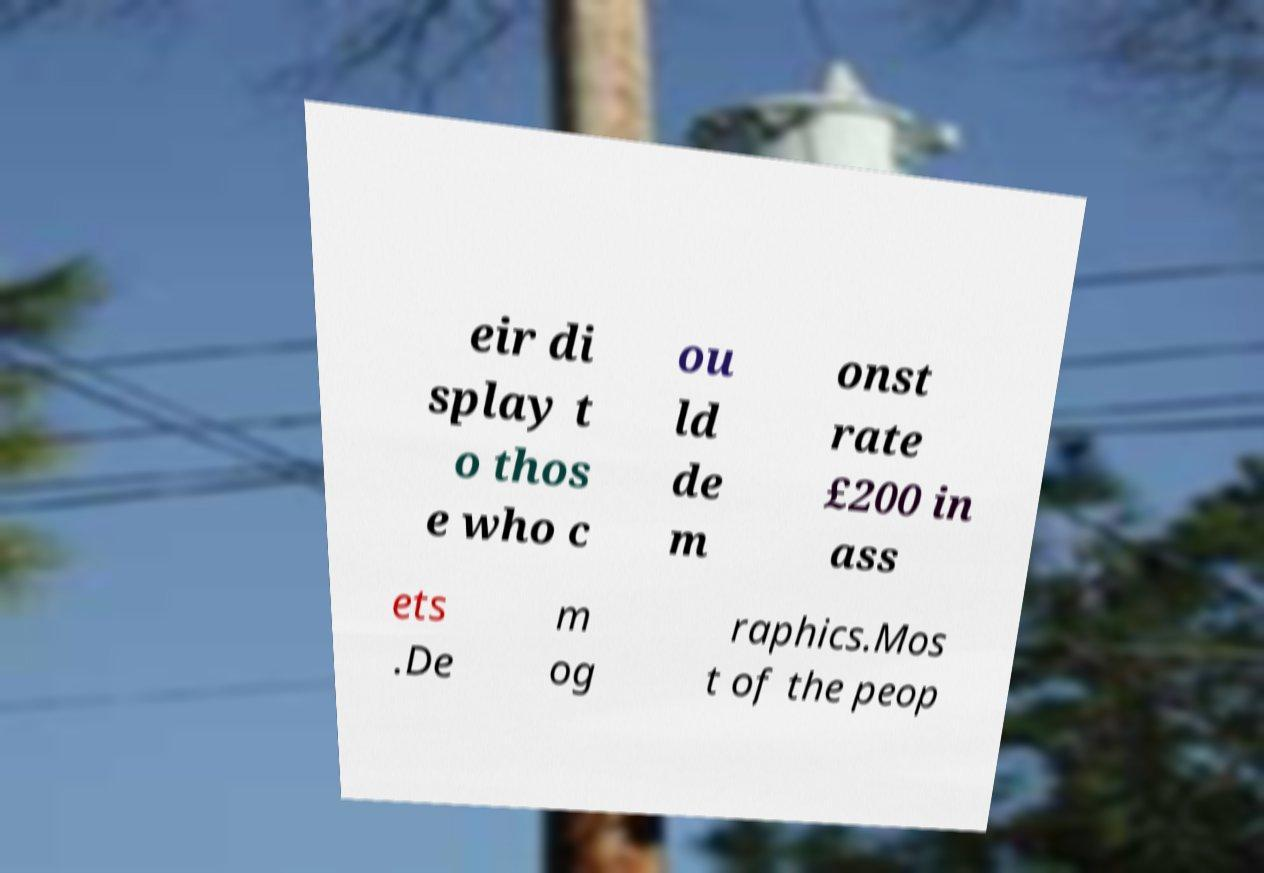Could you extract and type out the text from this image? eir di splay t o thos e who c ou ld de m onst rate £200 in ass ets .De m og raphics.Mos t of the peop 